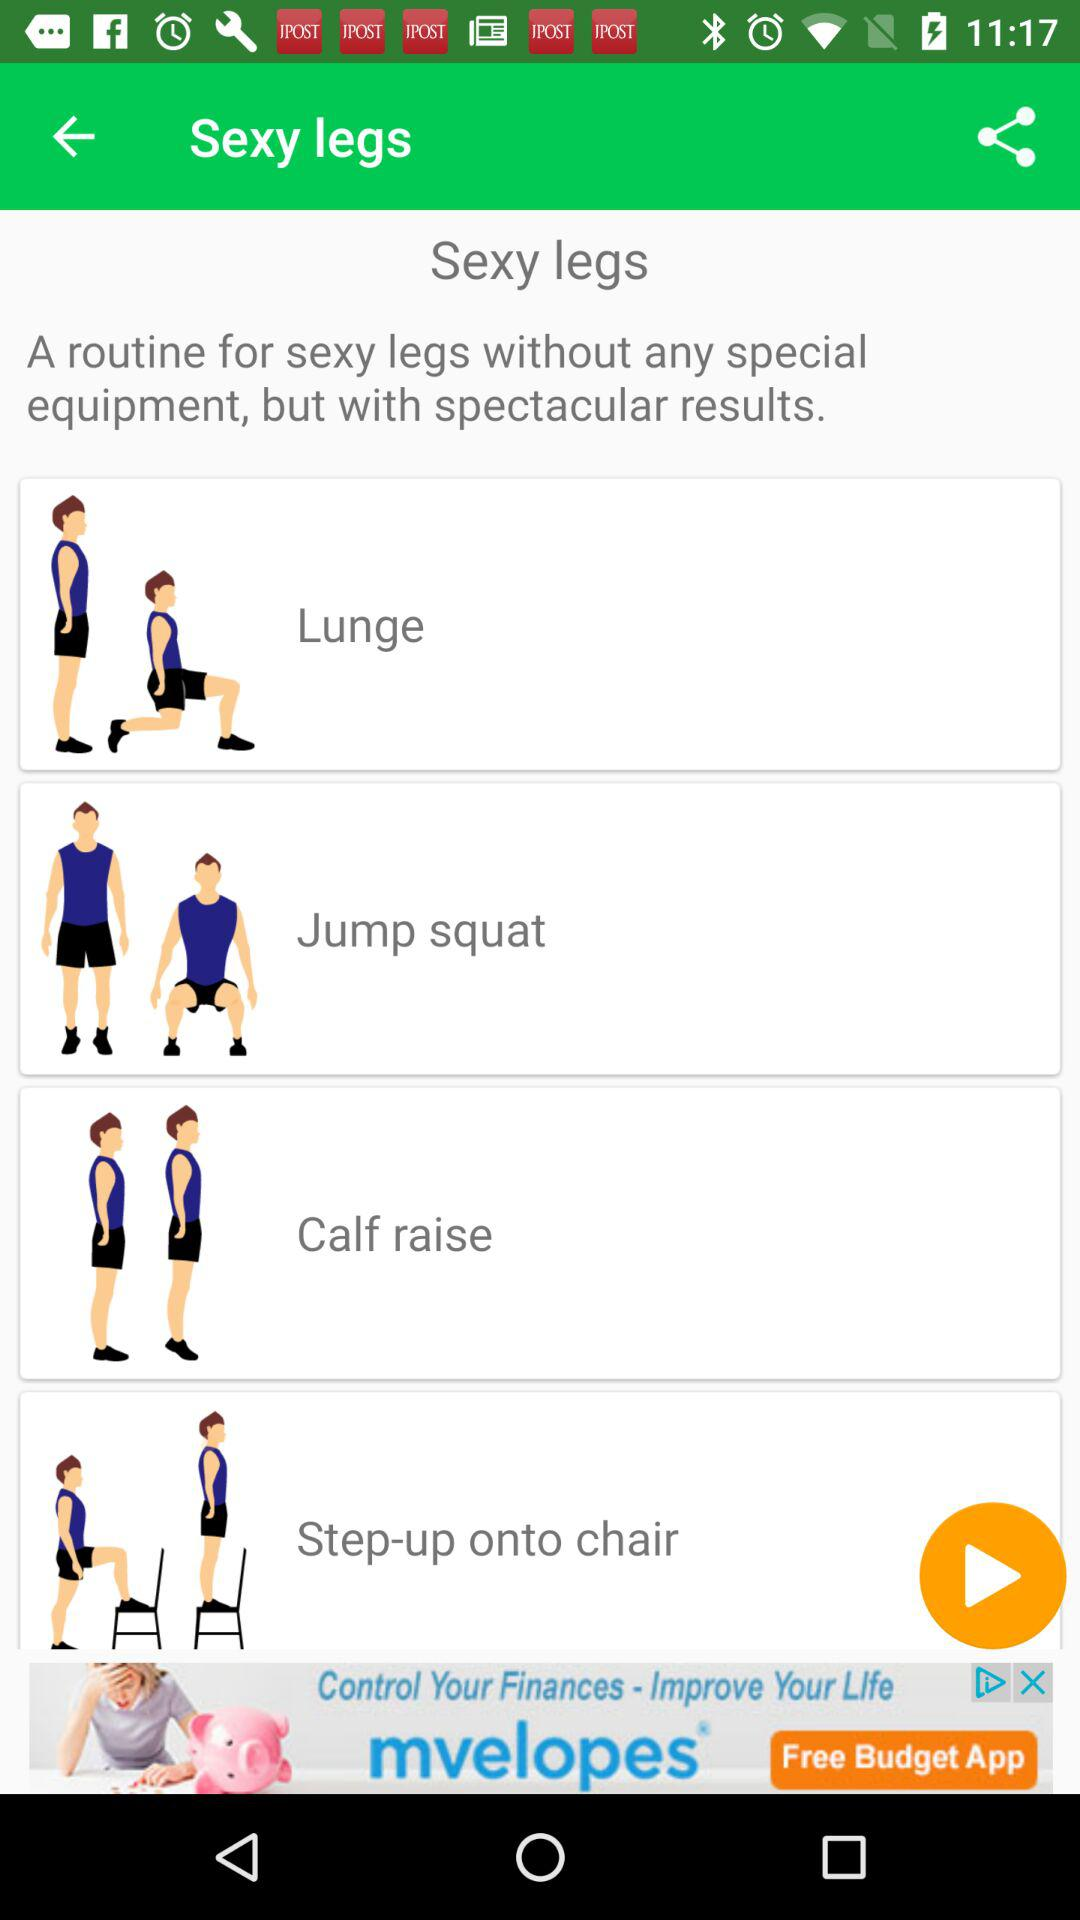What are the routine exercises for sexy legs? The routine exercises for sexy legs are "Lunge", "Jump squat", "Calf raise" and "Step-up onto chair". 